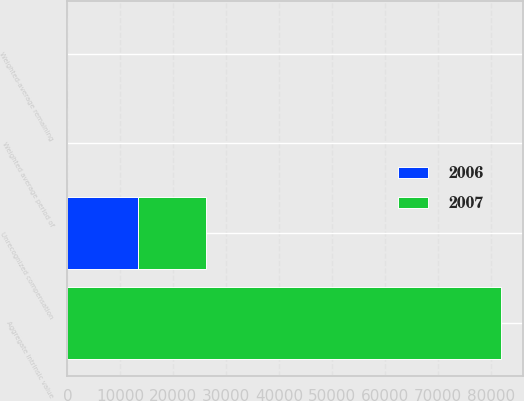Convert chart to OTSL. <chart><loc_0><loc_0><loc_500><loc_500><stacked_bar_chart><ecel><fcel>Weighted-average remaining<fcel>Aggregate intrinsic value<fcel>Unrecognized compensation<fcel>Weighted average period of<nl><fcel>2007<fcel>4.74<fcel>82006<fcel>12692<fcel>1.65<nl><fcel>2006<fcel>5.52<fcel>5.52<fcel>13414<fcel>2.46<nl></chart> 